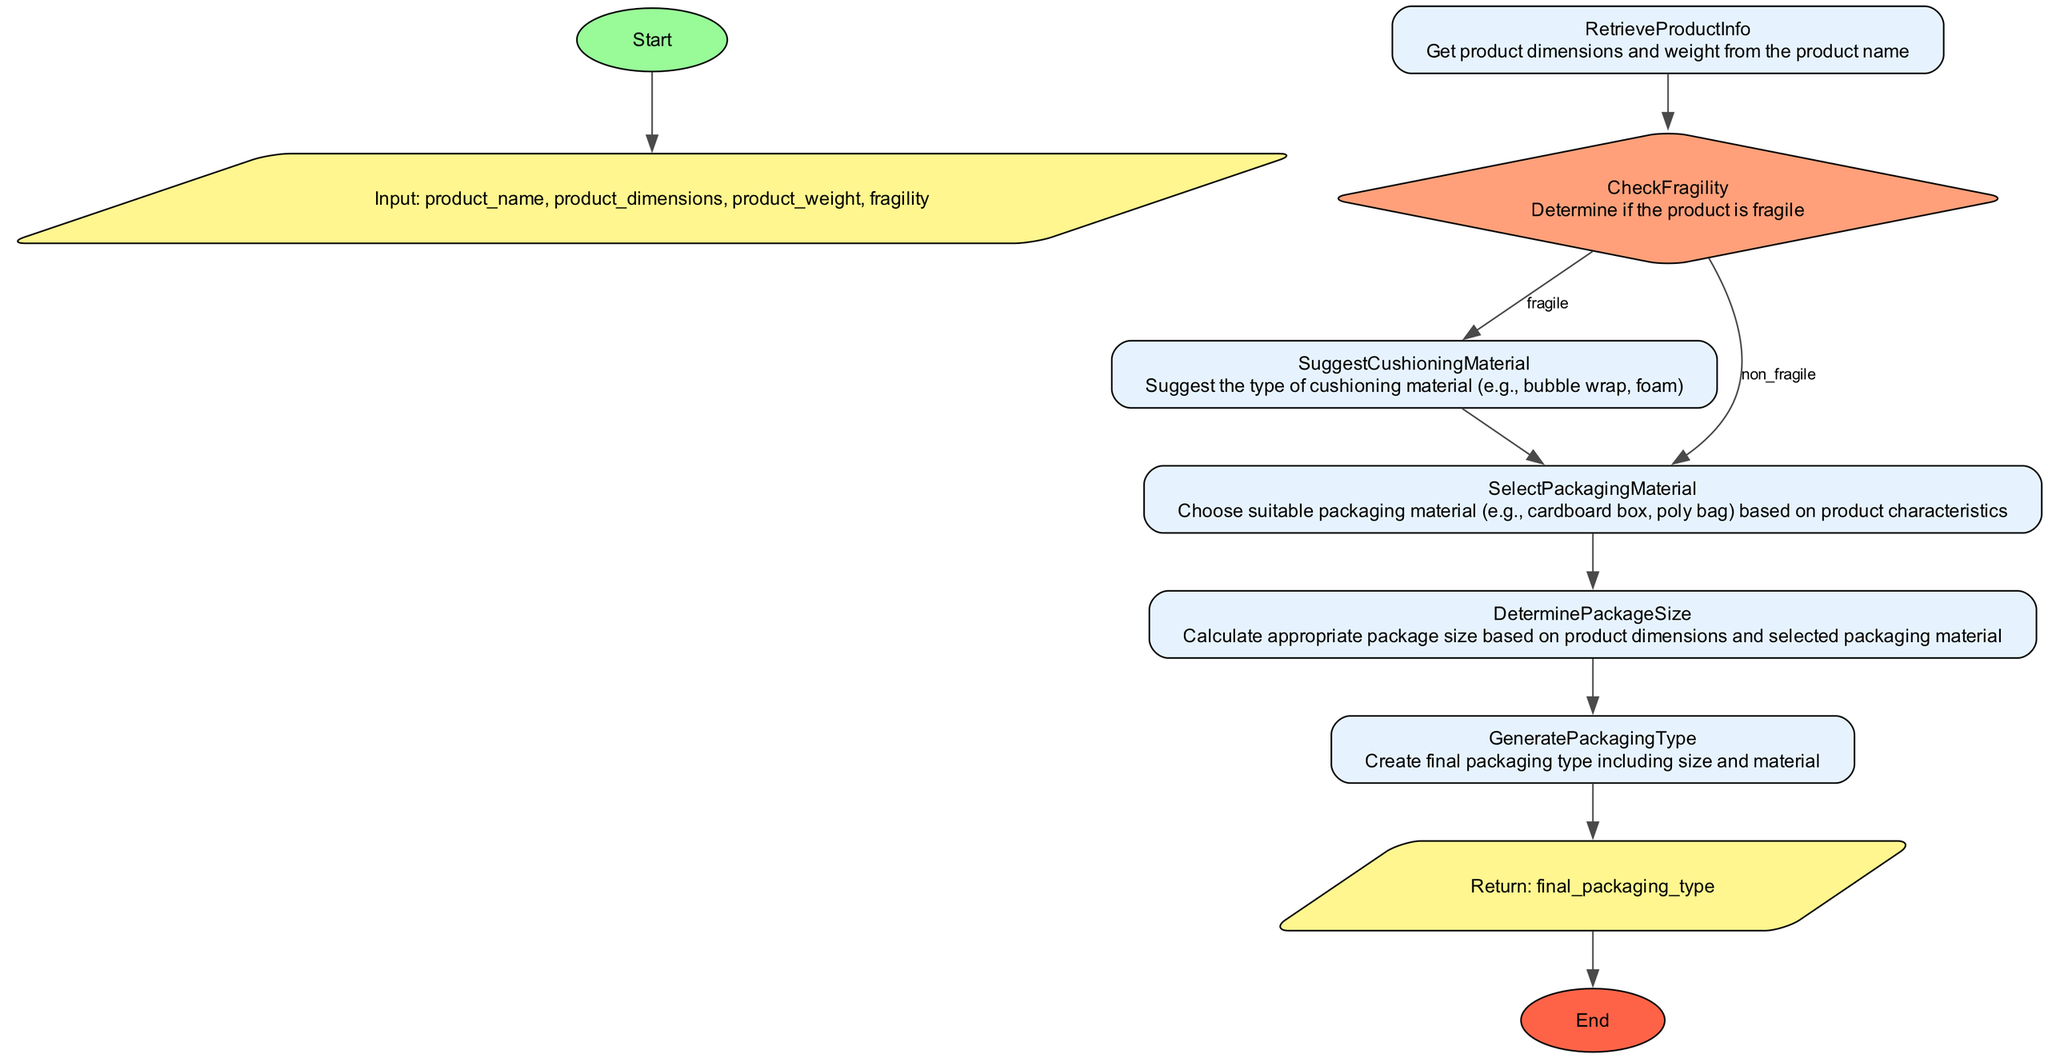What is the first action in the flowchart? The first action is the retrieval of product information, where the dimensions and weight are obtained using the product name.
Answer: RetrieveProductInfo How many conditions are there in the flowchart? There are two conditions: one for fragile products and one for non-fragile products, which direct the flow to different steps accordingly.
Answer: 2 What type of node follows the 'CheckFragility' node if the product is non-fragile? The next step after 'CheckFragility' for a non-fragile product is 'SelectPackagingMaterial'.
Answer: SelectPackagingMaterial What is the output of the 'SelectPackagingMaterial' node? The output produced by the 'SelectPackagingMaterial' node is the chosen packaging material for the product.
Answer: packaging_material What happens if the product is fragile? If the product is classified as fragile, the flowchart suggests cushioning material after the 'CheckFragility' node.
Answer: SuggestCushioningMaterial How is the package size determined? The package size is calculated based on the product dimensions along with the selected packaging material and any cushioning material.
Answer: DeterminePackageSize What is the role of the 'GeneratePackagingType' node? The 'GeneratePackagingType' node creates the final packaging type by combining the size and material selected in the previous steps.
Answer: final_packaging_type How many nodes are involved in the process of checking for fragility? There are two nodes involved when checking for fragility: 'CheckFragility' and 'SuggestCushioningMaterial'.
Answer: 2 What does the flowchart return at the end of the process? The flowchart returns the final packaging type after processing all necessary inputs and selections.
Answer: final_packaging_type 